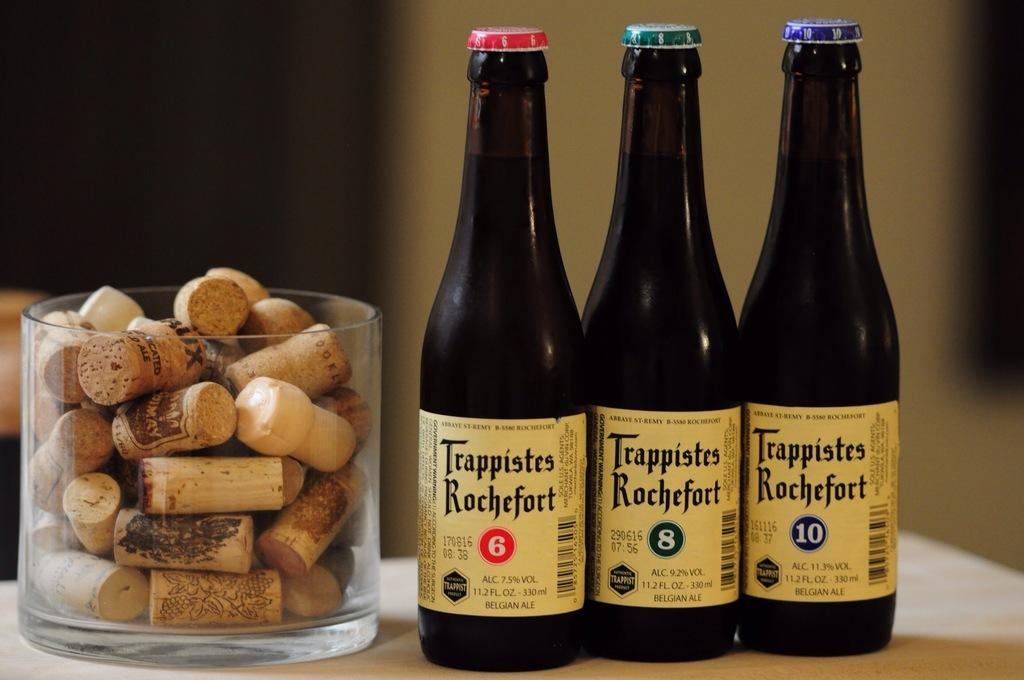<image>
Describe the image concisely. Bottles labeled 6, 8 and 10 are all made by Trappistes Rochefort. 